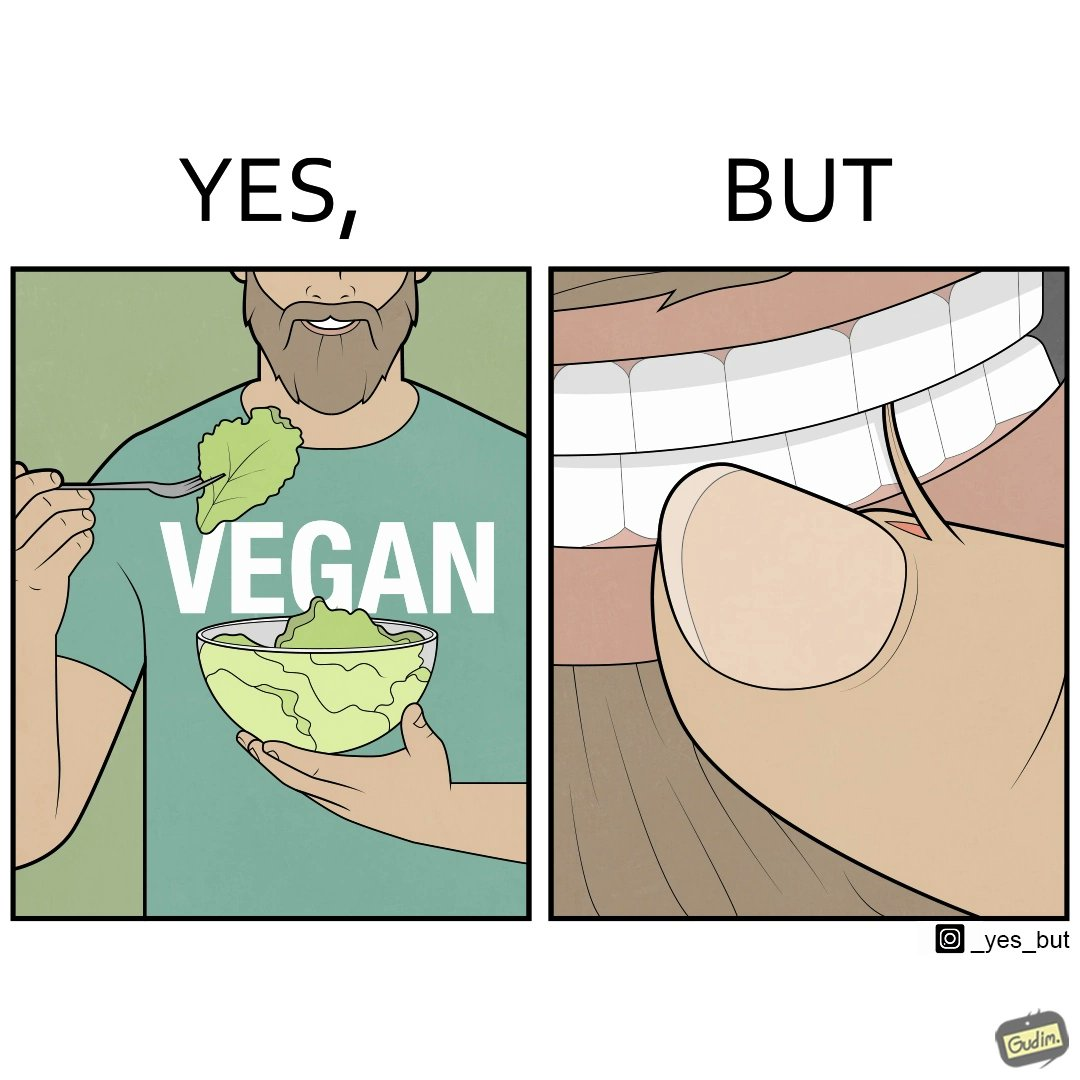Does this image contain satire or humor? Yes, this image is satirical. 